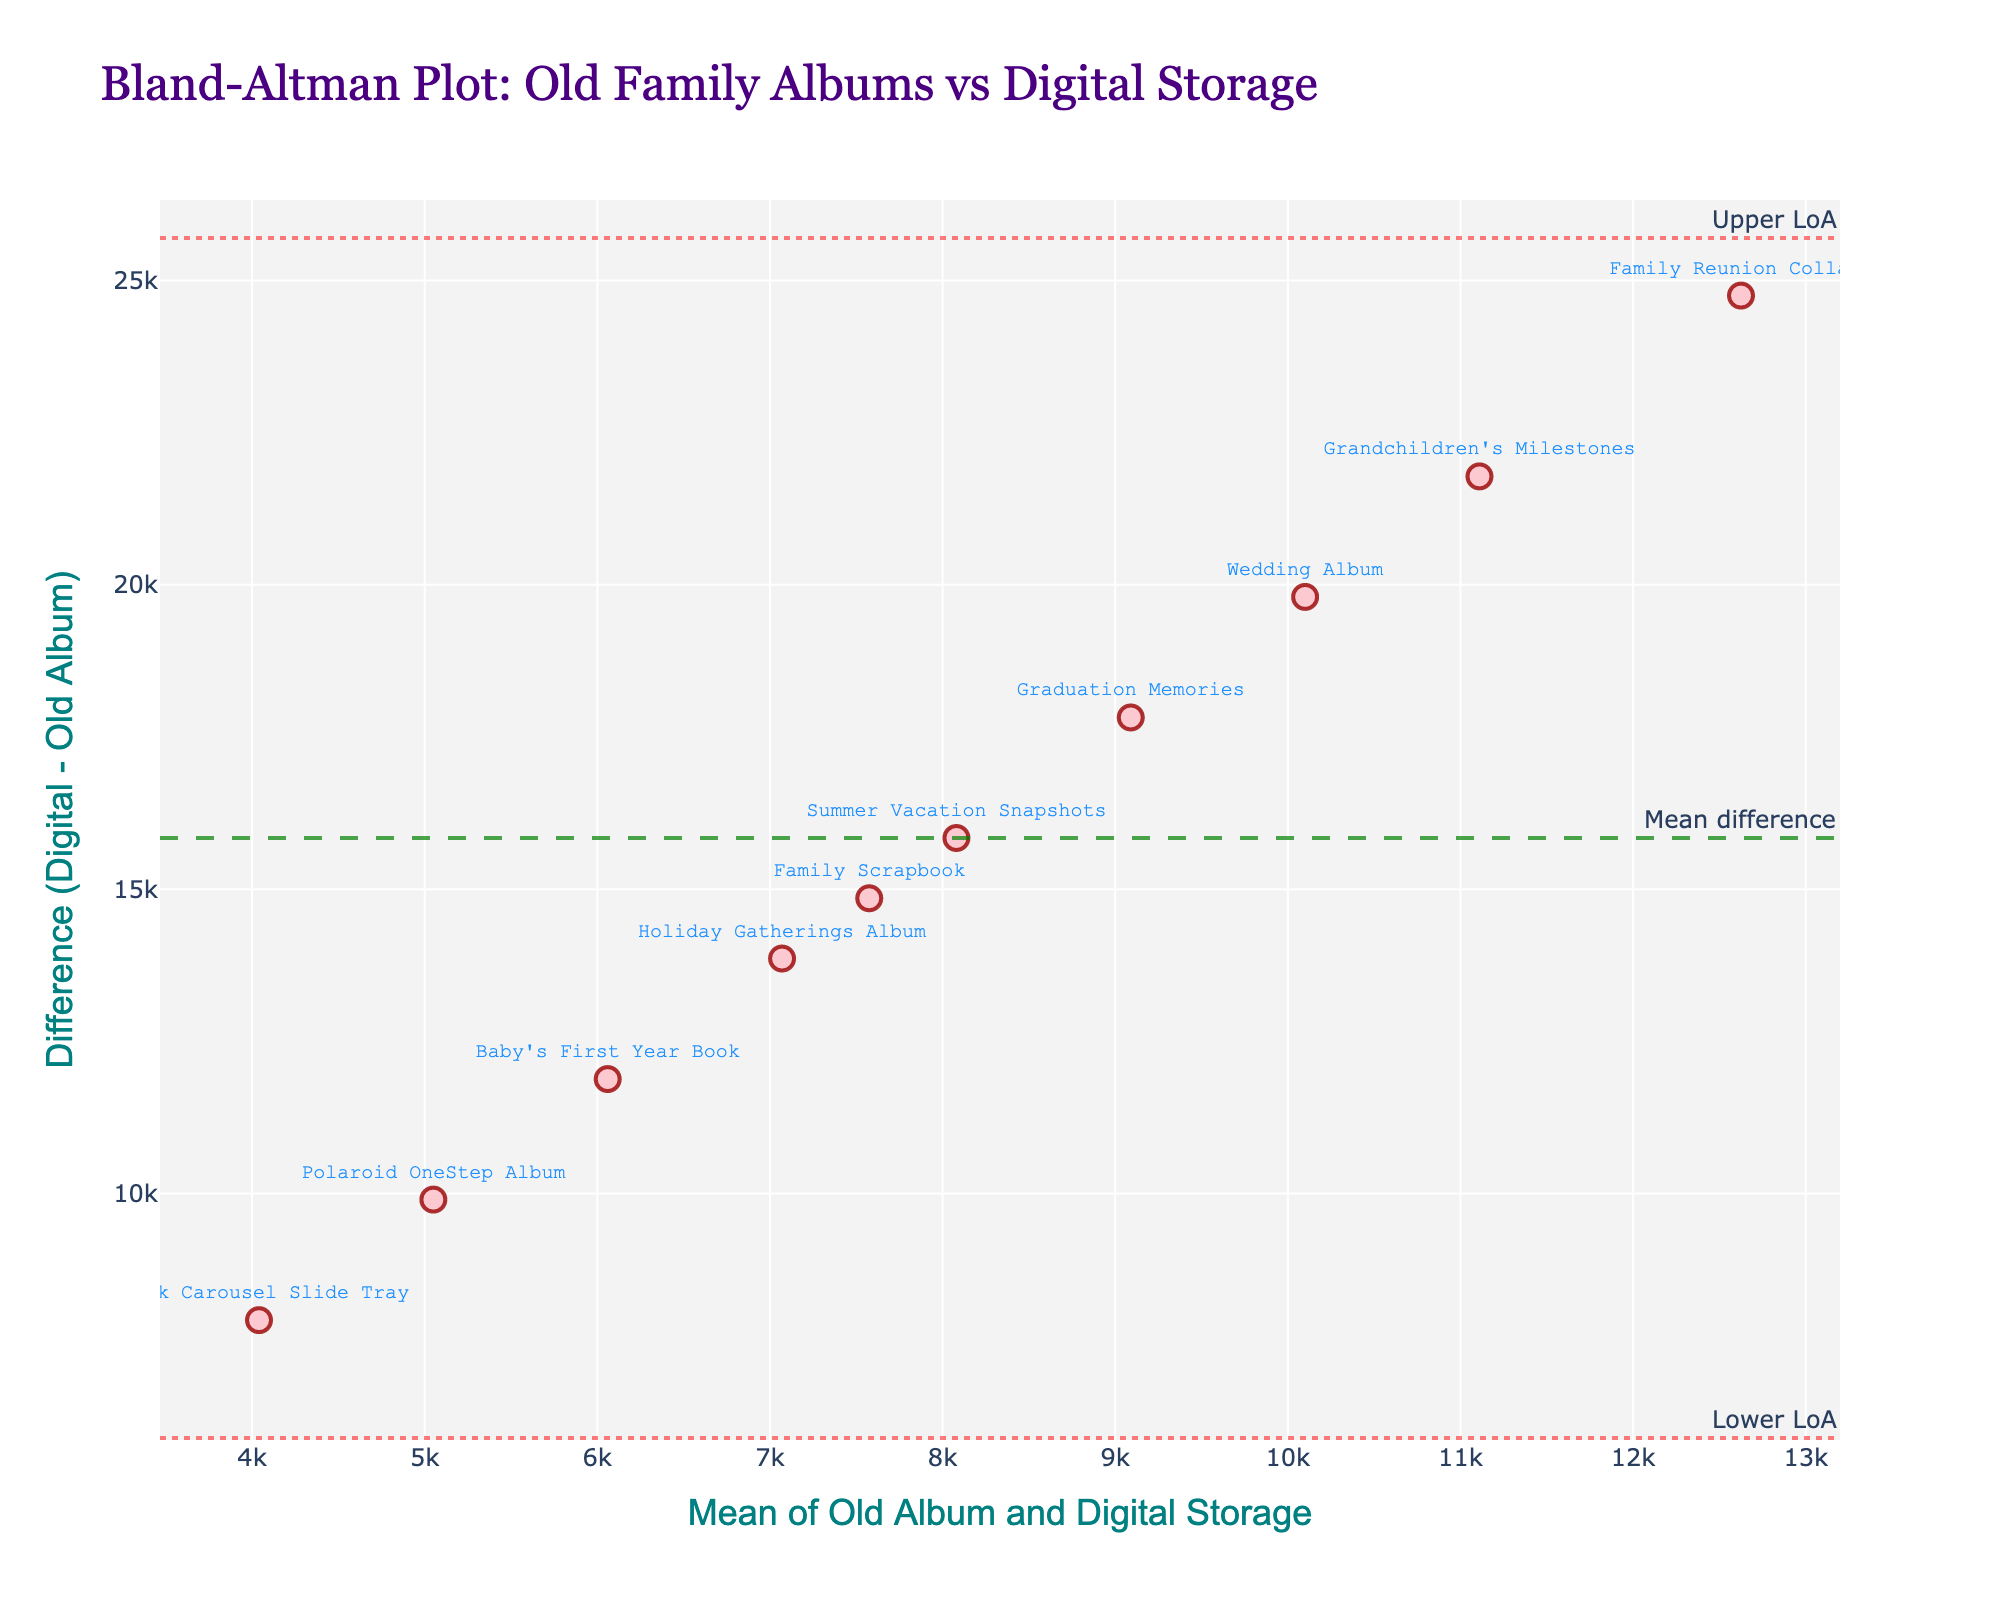what is the mean difference line annotated with? The figure has an annotated line representing the mean difference. There is a green dashed line with the annotation "Mean difference," indicating it as the mean difference line, which shows the overall mean of the differences between Digital Storage and Old Album sizes.
Answer: Mean difference How many albums are compared on the plot? The plot contains data points, each corresponding to a specific album comparison. There are 10 data points labeled with album names, indicating the comparison between Old Family Albums and Digital Storage capacities.
Answer: 10 What is the title of the Bland-Altman plot? The title of the Bland-Altman plot is a descriptive text found at the top of the figure. By checking the figure's header, one can see the exact title used for this plot.
Answer: Bland-Altman Plot: Old Family Albums vs Digital Storage What does the vertical (y-axis) represent? The vertical axis of the plot typically displays the difference between two measurements. Referring to the y-axis label on this particular figure will show that it represents the "Difference (Digital - Old Album)."
Answer: Difference (Digital - Old Album) Which album has the largest positive difference? By observing the scatter points on the plot, the vertical position gives the difference for each album. The album with the highest vertical value has the largest positive difference; in this case, "Family Reunion Collage," marked clearly above all others.
Answer: Family Reunion Collage What are the limits of agreement indicated in the plot? Limits of agreement are shown as two horizontal dotted lines on the Bland-Altman plot. The labels on the horizontal dotted lines indicate these limits, which are the upper and lower agreement bounds.
Answer: Upper LoA and Lower LoA Which album has the smallest mean size? To find the smallest mean size, locate the data point closest to the far left of the horizontal axis since the x-axis represents the mean size. "Kodak Carousel Slide Tray" is positioned closest to the y-axis, indicating the smallest mean size.
Answer: Kodak Carousel Slide Tray How does the 'Graduation Memories' album compare in difference to the mean difference? To compare this specific album, look for the point labeled "Graduation Memories" and check its vertical position concerning the green dashed line, which represents the mean difference. The 'Graduation Memories' album is below this line, meaning its difference is less than the mean difference.
Answer: Less than the mean difference What is the mean size of the 'Wedding Album'? The mean size for a specific album is given by the x-position of the point labeled with that album. Locate the "Wedding Album" point to read its horizontal value, which would be the mean of its Old Album and Digital Storage sizes ((200 + 20000)/2).
Answer: 10100 What is the sum of the highest mean size and the lowest mean size? First, identify the points with the highest and lowest x-values. The "Family Reunion Collage" has the highest mean size (250 + 25000)/2 = 12625, and "Kodak Carousel Slide Tray" has the lowest (80 + 8000)/2 = 4040. Adding these values gives the total. 12625 + 4040 = 16665.
Answer: 16665 